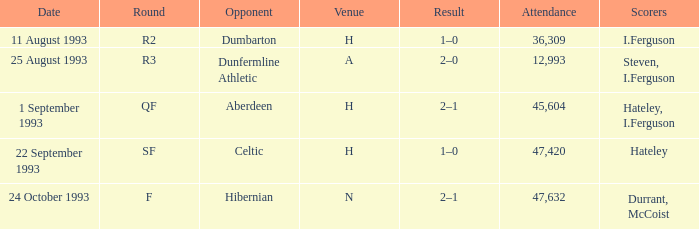What is the consequence for the round with f present? 2–1. 